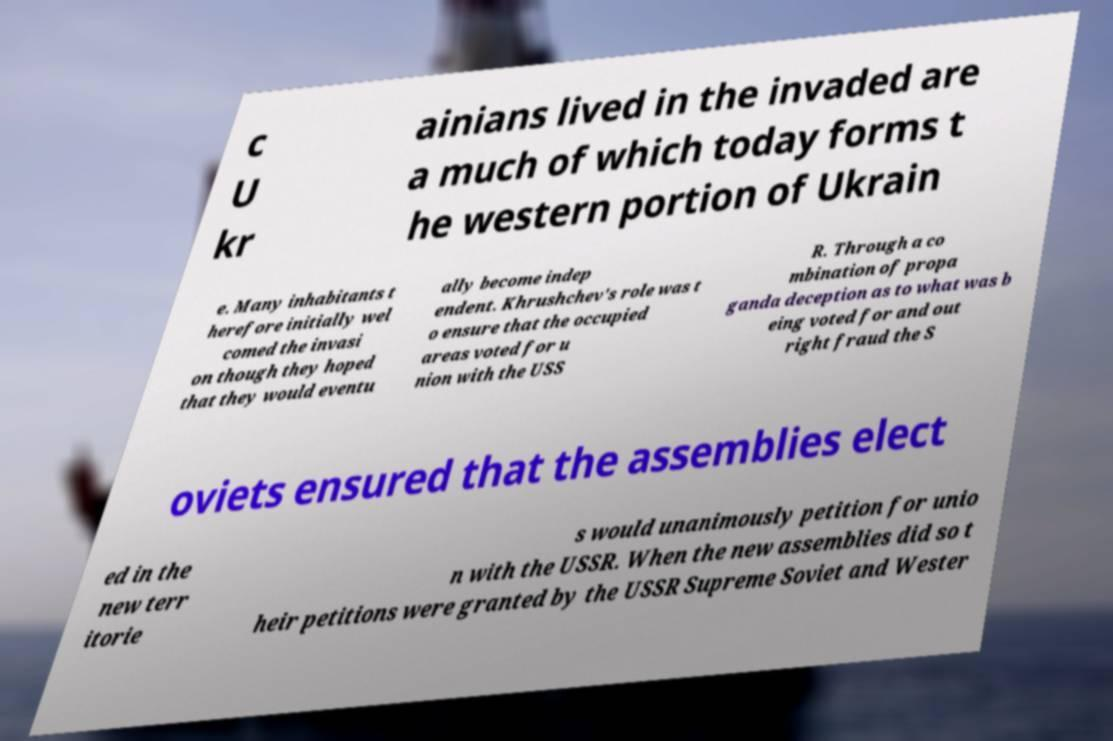Could you assist in decoding the text presented in this image and type it out clearly? c U kr ainians lived in the invaded are a much of which today forms t he western portion of Ukrain e. Many inhabitants t herefore initially wel comed the invasi on though they hoped that they would eventu ally become indep endent. Khrushchev's role was t o ensure that the occupied areas voted for u nion with the USS R. Through a co mbination of propa ganda deception as to what was b eing voted for and out right fraud the S oviets ensured that the assemblies elect ed in the new terr itorie s would unanimously petition for unio n with the USSR. When the new assemblies did so t heir petitions were granted by the USSR Supreme Soviet and Wester 